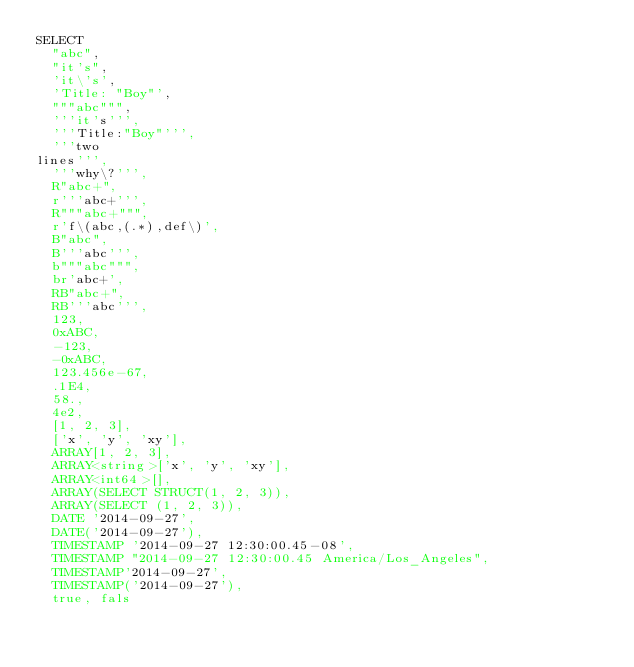Convert code to text. <code><loc_0><loc_0><loc_500><loc_500><_SQL_>SELECT
  "abc",
  "it's",
  'it\'s',
  'Title: "Boy"',
  """abc""",
  '''it's''',
  '''Title:"Boy"''',
  '''two
lines''',
  '''why\?''',
  R"abc+",
  r'''abc+''',
  R"""abc+""",
  r'f\(abc,(.*),def\)',
  B"abc",
  B'''abc''',
  b"""abc""",
  br'abc+',
  RB"abc+",
  RB'''abc''',
  123,
  0xABC,
  -123,
  -0xABC,
  123.456e-67,
  .1E4,
  58.,
  4e2,
  [1, 2, 3],
  ['x', 'y', 'xy'],
  ARRAY[1, 2, 3],
  ARRAY<string>['x', 'y', 'xy'],
  ARRAY<int64>[],
  ARRAY(SELECT STRUCT(1, 2, 3)),
  ARRAY(SELECT (1, 2, 3)),
  DATE '2014-09-27',
  DATE('2014-09-27'),
  TIMESTAMP '2014-09-27 12:30:00.45-08',
  TIMESTAMP "2014-09-27 12:30:00.45 America/Los_Angeles",
  TIMESTAMP'2014-09-27',
  TIMESTAMP('2014-09-27'),
  true, fals</code> 